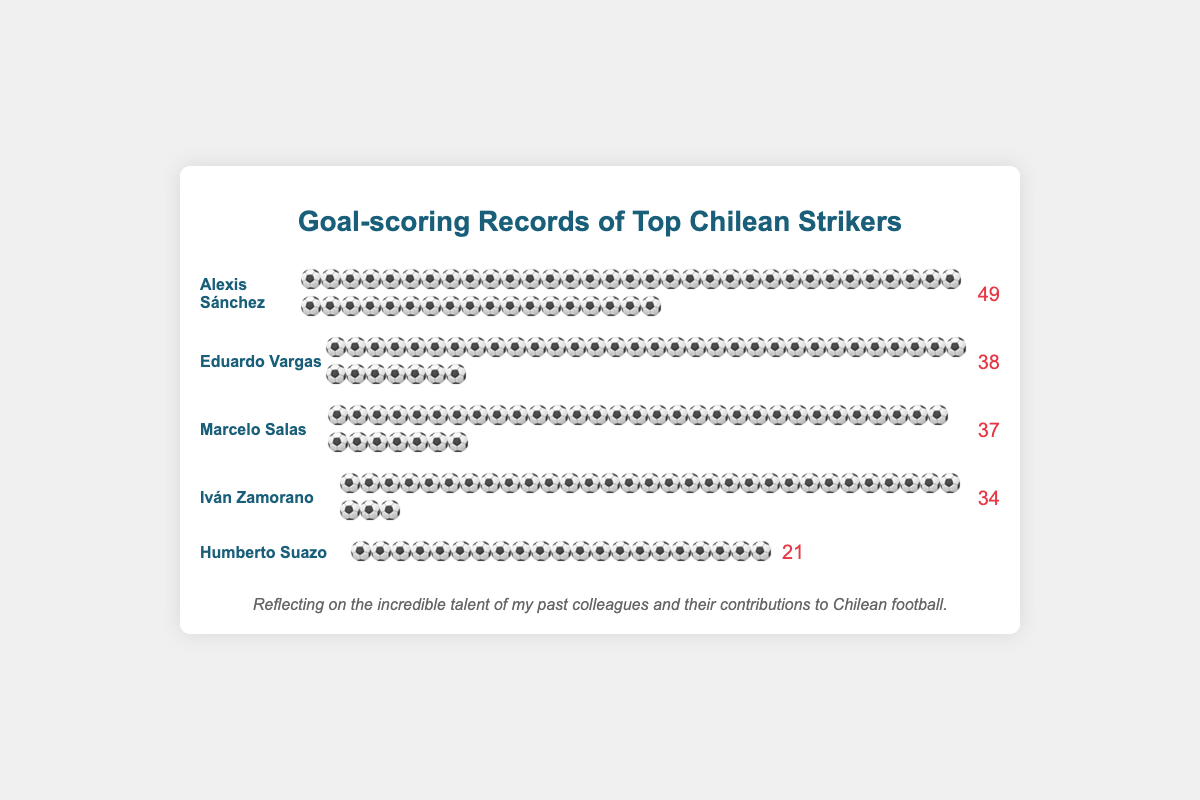Who scored the most goals among the top Chilean strikers? The striker with the most soccer ball icons representing goals scored will be the one with the highest number. Looking at the figure, Alexis Sánchez has the most icons.
Answer: Alexis Sánchez How many goals did Iván Zamorano score? Count the number of soccer ball icons next to Iván Zamorano's name. In the figure, Iván Zamorano has 34 soccer balls.
Answer: 34 Who scored more goals, Eduardo Vargas or Marcelo Salas? Compare the number of soccer ball icons next to Eduardo Vargas and Marcelo Salas' names. Eduardo Vargas has 38 and Marcelo Salas has 37. So, Eduardo Vargas scored more.
Answer: Eduardo Vargas What is the total number of goals scored by Iván Zamorano and Humberto Suazo combined? Add together the number of goals from Iván Zamorano (34 icons) and Humberto Suazo (21 icons): 34 + 21 = 55.
Answer: 55 Which striker scored the fewest goals? The striker with the least number of soccer ball icons will be the one with the fewest goals. Humberto Suazo has the least number of icons.
Answer: Humberto Suazo How many more goals did Alexis Sánchez score than Iván Zamorano? Subtract the number of goals by Iván Zamorano (34) from Alexis Sánchez's total (49): 49 - 34 = 15.
Answer: 15 What is the average number of goals scored by the given strikers? Calculate the sum of the goals scored by all the strikers and then divide by the number of strikers. (34 + 37 + 49 + 38 + 21) / 5 = 179 / 5 = 35.8.
Answer: 35.8 How many strikers scored more than 35 goals? Look at each striker and count how many have more than 35 soccer ball icons. Alexis Sánchez (49), Eduardo Vargas (38), and Marcelo Salas (37) each have more than 35. So, the answer is 3 strikers.
Answer: 3 